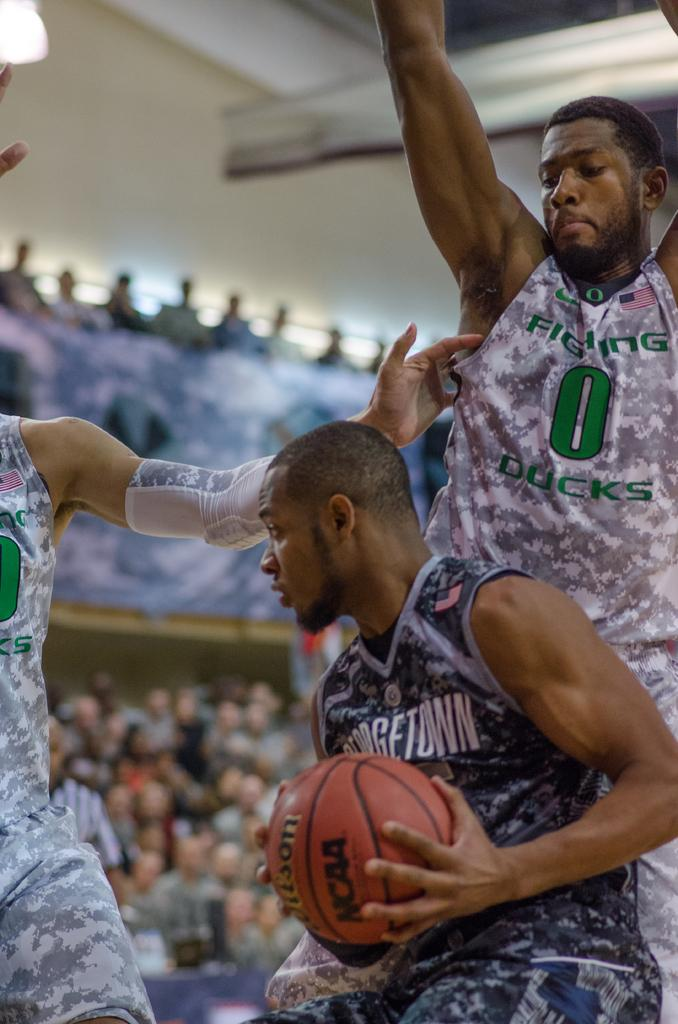How many people are in the image? There are people in the image, but the exact number is not specified. What is the man holding in his hands? The man is holding a ball in his hands. What can be seen in the background of the image? There is a group of audience in the background of the image. What type of needle is the man using to sew the clam in the image? There is no needle or clam present in the image. 